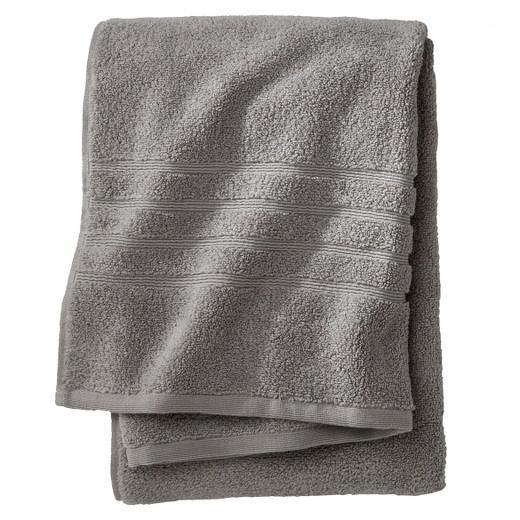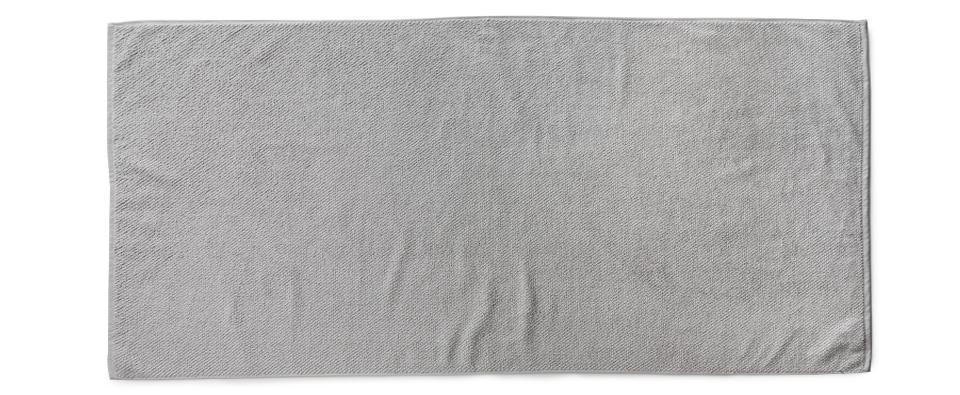The first image is the image on the left, the second image is the image on the right. Given the left and right images, does the statement "Fabric color is obviously grey." hold true? Answer yes or no. Yes. 